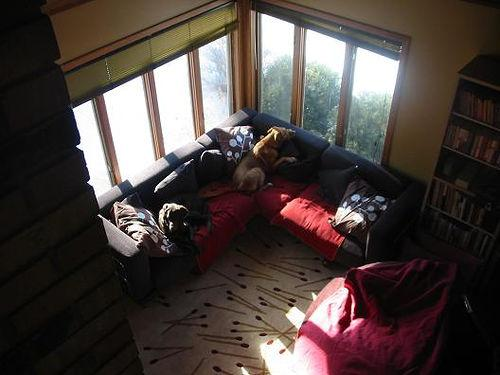What is on the couch? dogs 